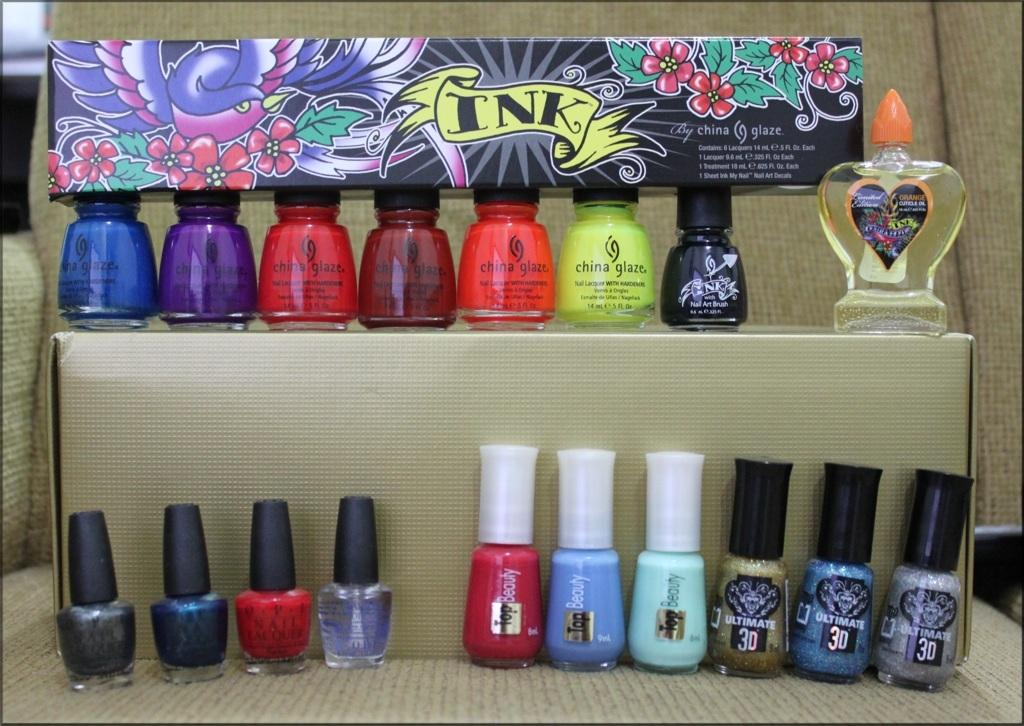What is the main subject in the center of the image? There is nail polish in the center of the image. What else can be seen in the image besides the nail polish? There are boxes present in the image. Can you describe the background of the image? There is a chair in the background of the image. What type of nerve can be seen in the image? There is no nerve present in the image; it features nail polish and boxes. What disease is depicted in the image? There is no disease depicted in the image; it features nail polish and boxes. 